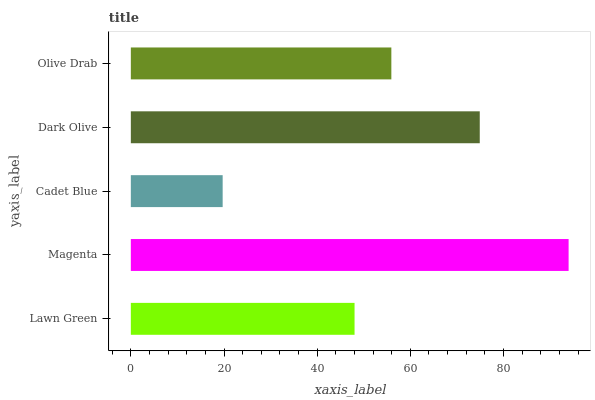Is Cadet Blue the minimum?
Answer yes or no. Yes. Is Magenta the maximum?
Answer yes or no. Yes. Is Magenta the minimum?
Answer yes or no. No. Is Cadet Blue the maximum?
Answer yes or no. No. Is Magenta greater than Cadet Blue?
Answer yes or no. Yes. Is Cadet Blue less than Magenta?
Answer yes or no. Yes. Is Cadet Blue greater than Magenta?
Answer yes or no. No. Is Magenta less than Cadet Blue?
Answer yes or no. No. Is Olive Drab the high median?
Answer yes or no. Yes. Is Olive Drab the low median?
Answer yes or no. Yes. Is Cadet Blue the high median?
Answer yes or no. No. Is Cadet Blue the low median?
Answer yes or no. No. 